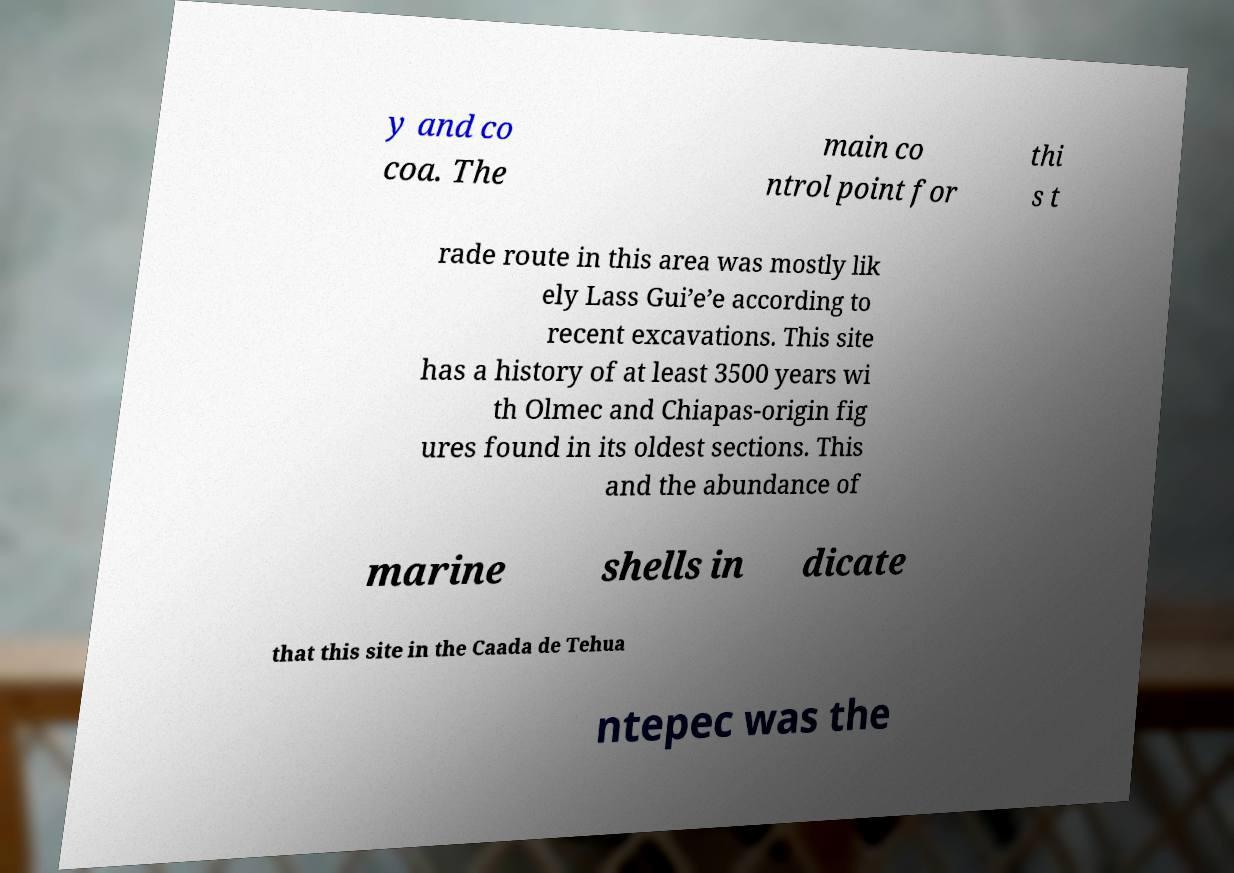Can you read and provide the text displayed in the image?This photo seems to have some interesting text. Can you extract and type it out for me? y and co coa. The main co ntrol point for thi s t rade route in this area was mostly lik ely Lass Gui’e’e according to recent excavations. This site has a history of at least 3500 years wi th Olmec and Chiapas-origin fig ures found in its oldest sections. This and the abundance of marine shells in dicate that this site in the Caada de Tehua ntepec was the 